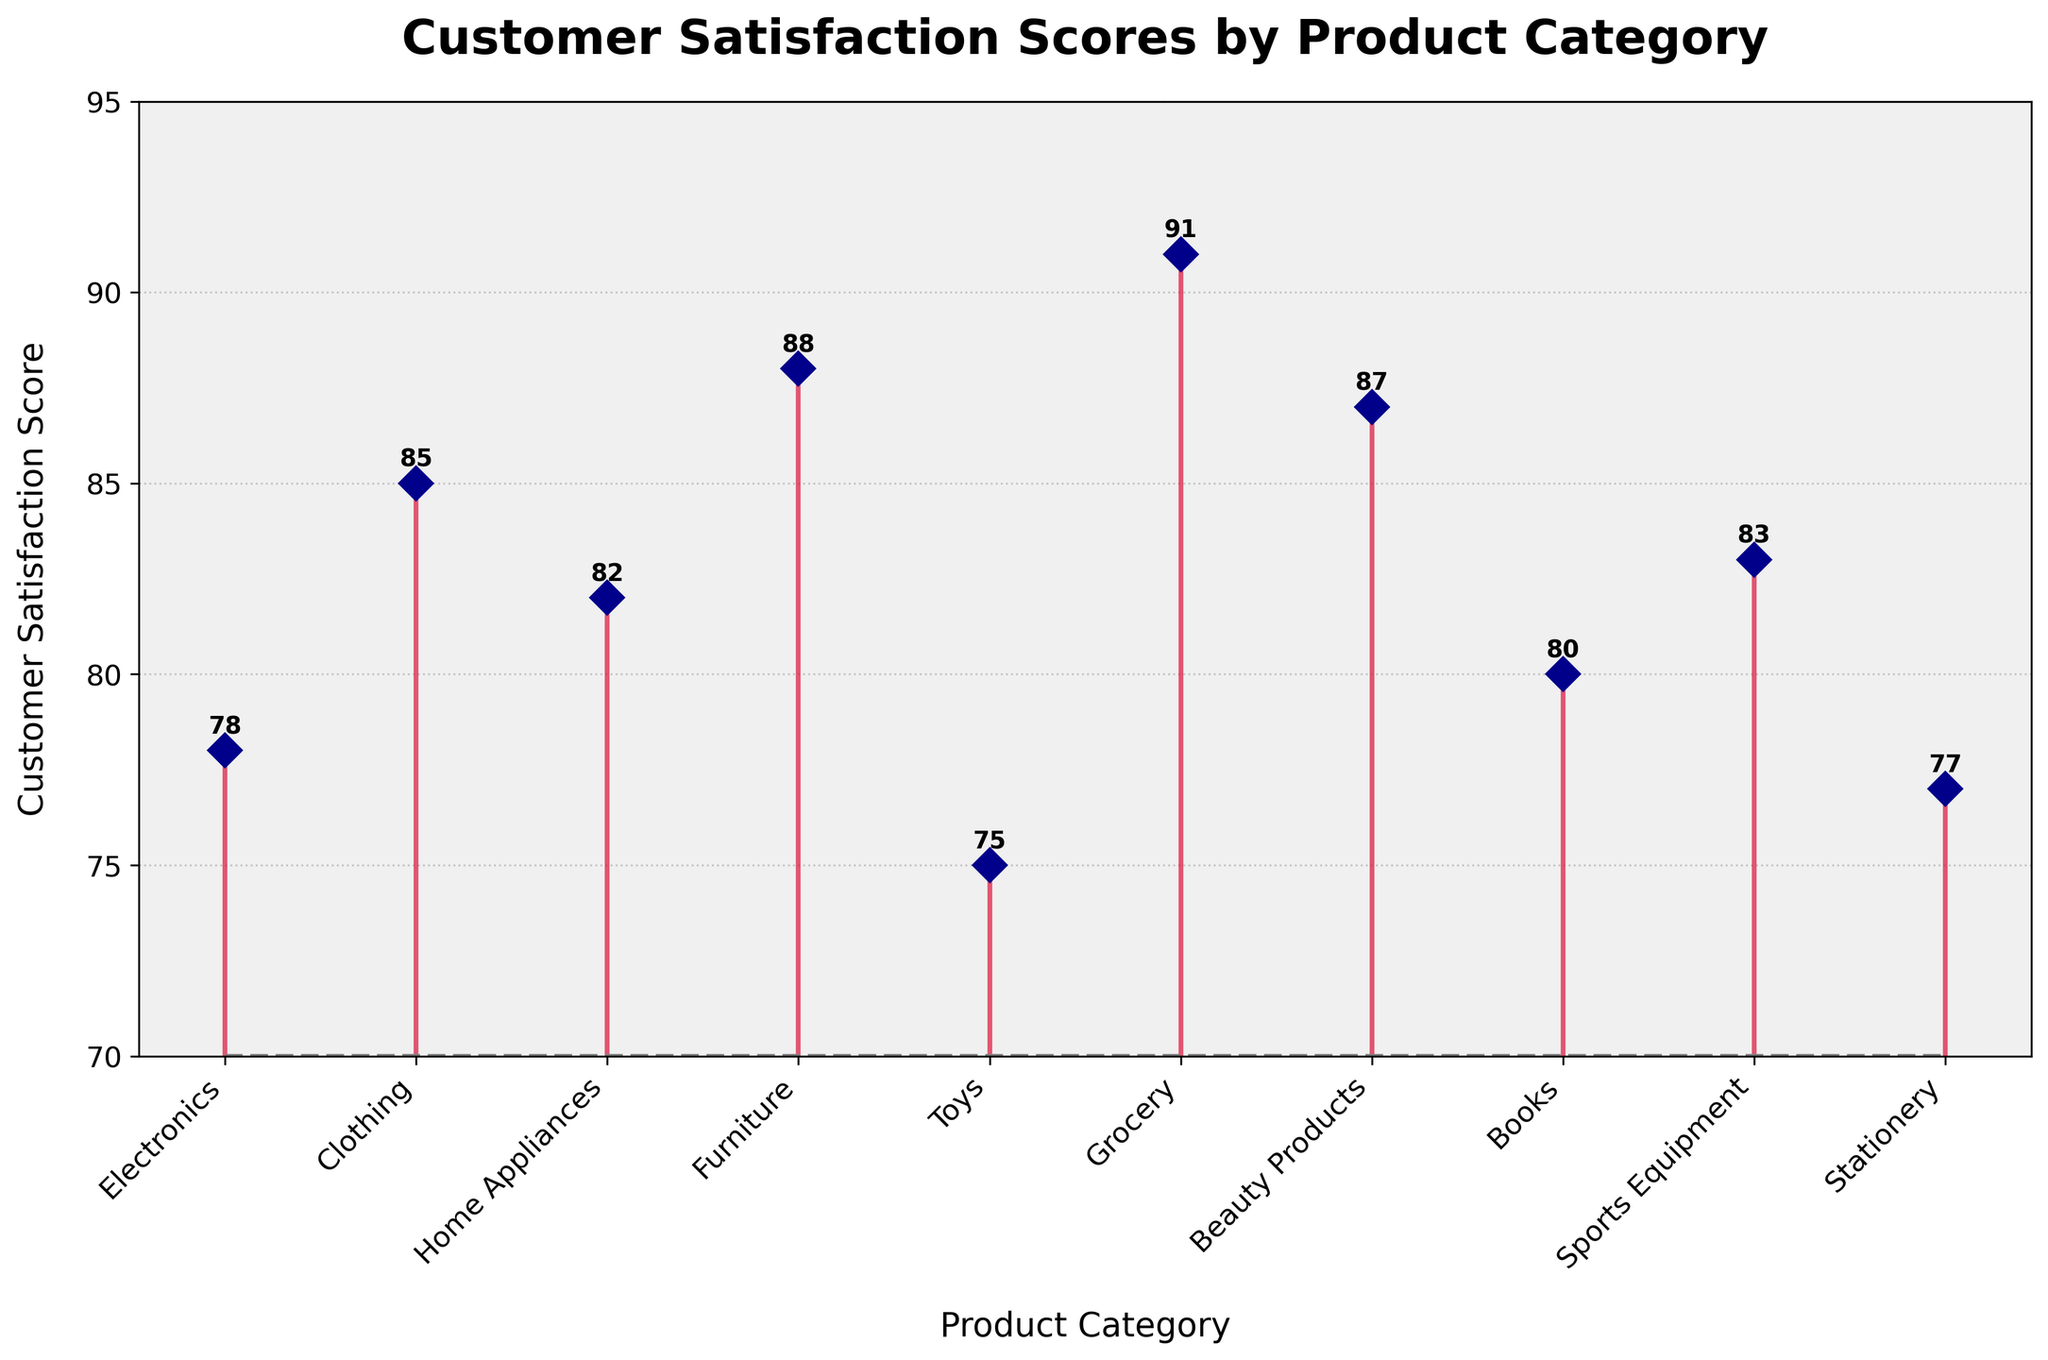What is the title of the plot? The title of the plot is displayed at the top, and it reads "Customer Satisfaction Scores by Product Category"
Answer: Customer Satisfaction Scores by Product Category How many product categories are listed in the plot? The plot displays each product category along the x-axis. Counting them gives the total number of categories
Answer: 10 Which product category has the highest customer satisfaction score? By looking at the highest point on the vertical axis corresponding to a product category, we see that "Grocery" has the highest score
Answer: Grocery What is the customer satisfaction score for Toys? Locate the "Toys" category along the x-axis and refer to the corresponding point on the y-axis to find the score
Answer: 75 Which product categories have scores greater than 80 but less than 85? Identify the product categories with their corresponding scores between 80 and 85 by analyzing the y-axis values
Answer: Sports Equipment, Home Appliances, Books What is the difference in customer satisfaction score between the highest and lowest scoring categories? The highest score is for Grocery (91) and the lowest is for Toys (75). Subtracting 75 from 91 gives the difference
Answer: 16 What’s the median customer satisfaction score across all product categories? List all the scores in ascending order: 75, 77, 78, 80, 82, 83, 85, 87, 88, 91. The middle numbers are 82 and 83. The median would be the average of these two
Answer: 82.5 Which product categories have a customer satisfaction score exactly equal to 77? Locate the categories whose score corresponds to the value of 77 on the y-axis
Answer: Stationery How many product categories have customer satisfaction scores below 80? Count the categories with their corresponding scores below 80 by analyzing the plotted points
Answer: 3 Is the customer satisfaction score for Electronics higher or lower than for Books? Compare the scores of Electronics (78) and Books (80) by checking the respective points on the y-axis
Answer: Lower 